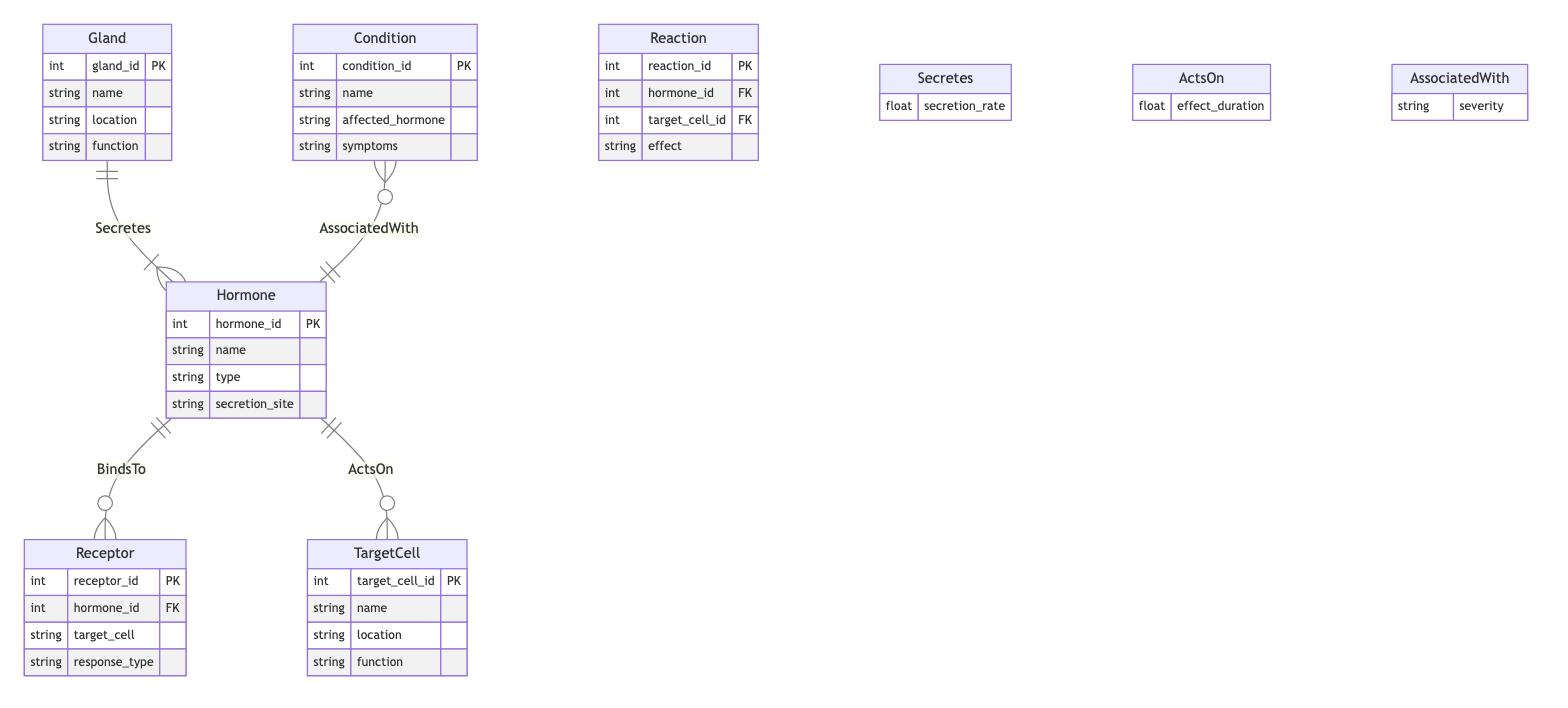What are the attributes of the Hormone entity? The Hormone entity has the following attributes: hormone_id, name, type, and secretion_site, as listed in the data section of the diagram.
Answer: hormone_id, name, type, secretion_site How many entities are represented in the diagram? The diagram includes six entities: Hormone, Gland, Receptor, TargetCell, Reaction, and Condition, totaling six entities.
Answer: six What relationship connects Gland to Hormone? The relationship connecting Gland to Hormone is labeled "Secretes," indicating that glands secrete hormones.
Answer: Secretes Which entity is characterized by "effect_duration"? The entity characterized by "effect_duration" is the relationship "ActsOn," which describes how hormones act on target cells and includes the duration of the effect.
Answer: ActsOn What is the function of the TargetCell entity? The function of the TargetCell entity is described by its attributes; it specifically includes a name, location, and function, but the exact function is not listed in the provided data.
Answer: function What condition is associated with the Hormone based on their relationship? The relationship "AssociatedWith" links the Condition entity to the Hormone entity, indicating that conditions can be associated with specific hormones.
Answer: AssociatedWith Which entity has a relationship with symptoms? The entity associated with symptoms is the Condition, as it includes symptoms as one of its attributes that describes conditions affecting hormonal health.
Answer: Condition What attribute describes the severity of the relationship between Condition and Hormone? The attribute that describes the severity of the relationship between Condition and Hormone is "severity," which indicates the level of impact a condition has on a hormone.
Answer: severity Which entity has a receiving relationship described by "BindsTo"? The Receptor entity has a relationship described by "BindsTo" with the Hormone entity, indicating that receptors bind to hormones to initiate responses in target cells.
Answer: Receptor 